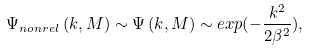<formula> <loc_0><loc_0><loc_500><loc_500>\Psi _ { n o n r e l } \left ( k , M \right ) \sim \Psi \left ( k , M \right ) \sim e x p ( - \frac { k ^ { 2 } } { 2 \beta ^ { 2 } } ) ,</formula> 